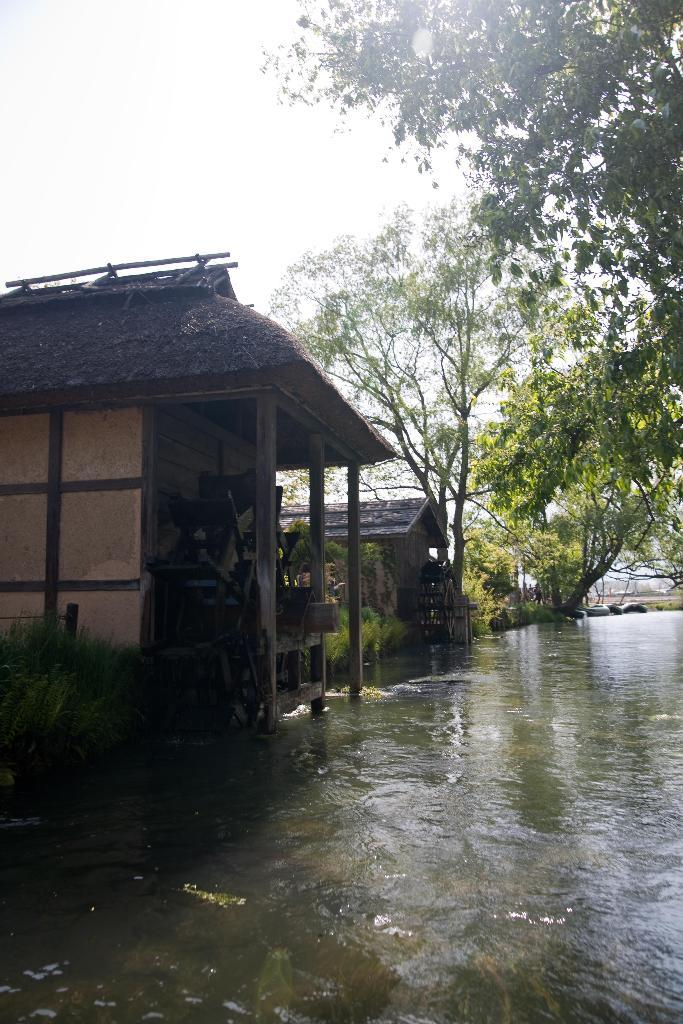What is visible in the image? Water is visible in the image. What can be seen near the water? There are many trees and houses near the water. What is visible in the background of the image? The sky is visible in the background of the image. What type of nose can be seen on the trees near the water? There are no noses present on the trees in the image. 